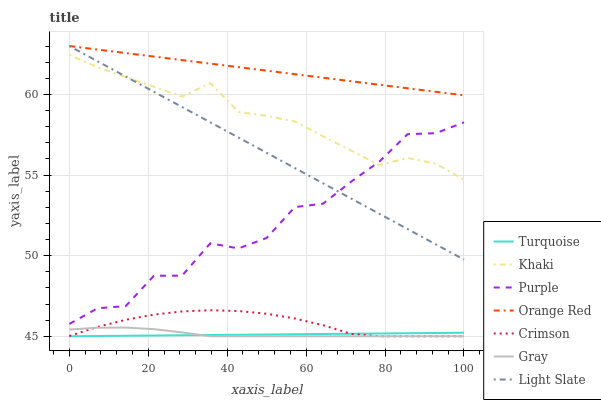Does Turquoise have the minimum area under the curve?
Answer yes or no. Yes. Does Orange Red have the maximum area under the curve?
Answer yes or no. Yes. Does Khaki have the minimum area under the curve?
Answer yes or no. No. Does Khaki have the maximum area under the curve?
Answer yes or no. No. Is Turquoise the smoothest?
Answer yes or no. Yes. Is Purple the roughest?
Answer yes or no. Yes. Is Khaki the smoothest?
Answer yes or no. No. Is Khaki the roughest?
Answer yes or no. No. Does Khaki have the lowest value?
Answer yes or no. No. Does Orange Red have the highest value?
Answer yes or no. Yes. Does Khaki have the highest value?
Answer yes or no. No. Is Gray less than Purple?
Answer yes or no. Yes. Is Orange Red greater than Turquoise?
Answer yes or no. Yes. Does Gray intersect Crimson?
Answer yes or no. Yes. Is Gray less than Crimson?
Answer yes or no. No. Is Gray greater than Crimson?
Answer yes or no. No. Does Gray intersect Purple?
Answer yes or no. No. 